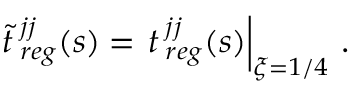Convert formula to latex. <formula><loc_0><loc_0><loc_500><loc_500>{ \tilde { t } } { \, } _ { r e g } ^ { j j } ( s ) = t { \, } _ { r e g } ^ { j j } ( s ) \right | _ { \xi = 1 / 4 } \, .</formula> 